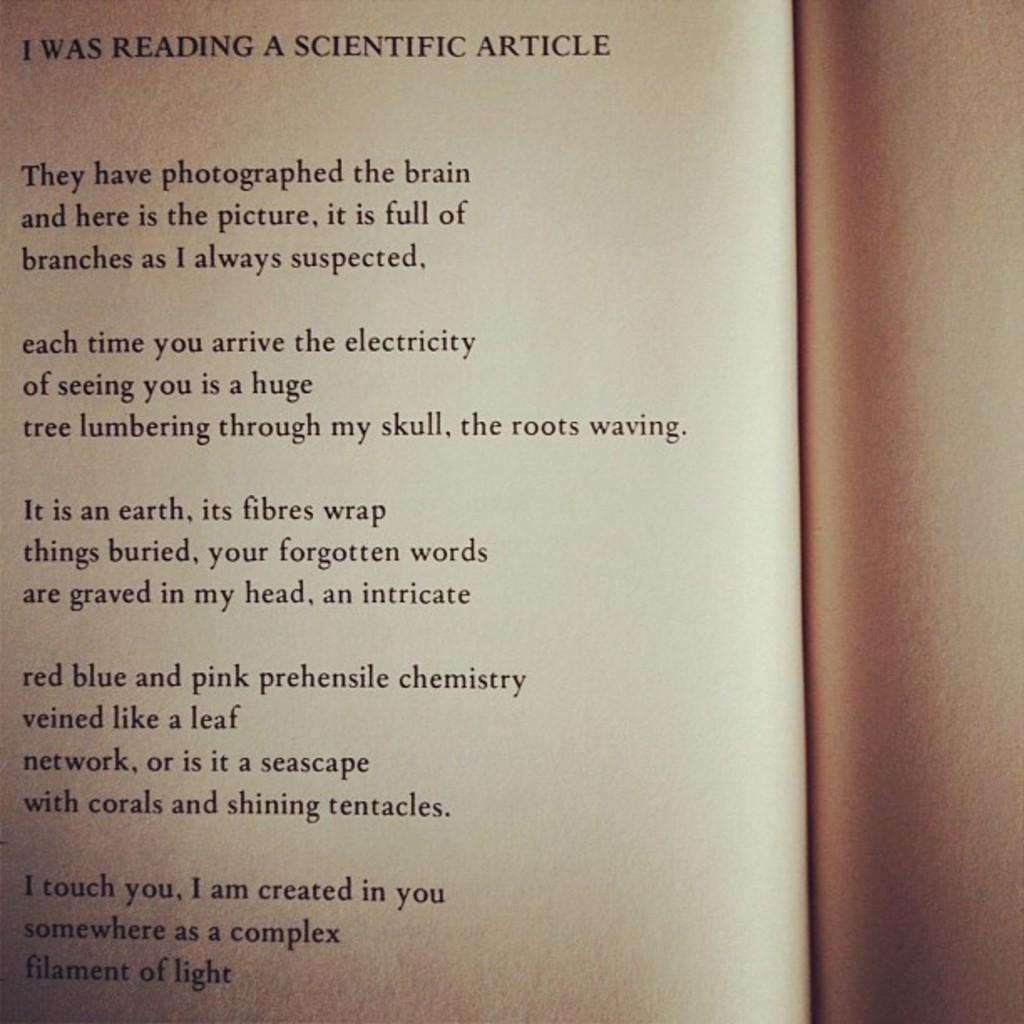Provide a one-sentence caption for the provided image. THE PAGE OF A BOOK WITH PARAGRAPHS OF POETRY. 